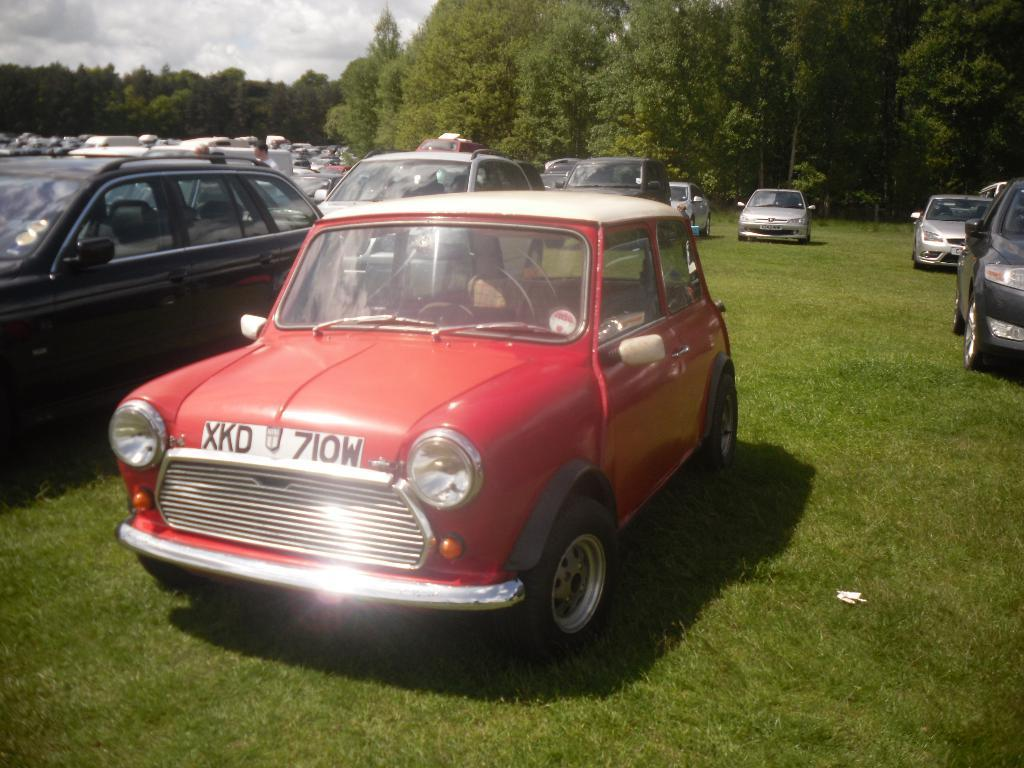What types of vehicles can be seen in the image? There are many vehicles in the image. What is the ground surface like in the image? There is grass on the ground in the image. What can be seen in the background of the image? There are trees in the background of the image. What is visible above the vehicles and trees in the image? The sky is visible in the image. What types of toys can be seen in the image? There are no toys present in the image; it features vehicles, grass, trees, and the sky. 